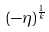Convert formula to latex. <formula><loc_0><loc_0><loc_500><loc_500>( - \eta ) ^ { \frac { 1 } { k } }</formula> 